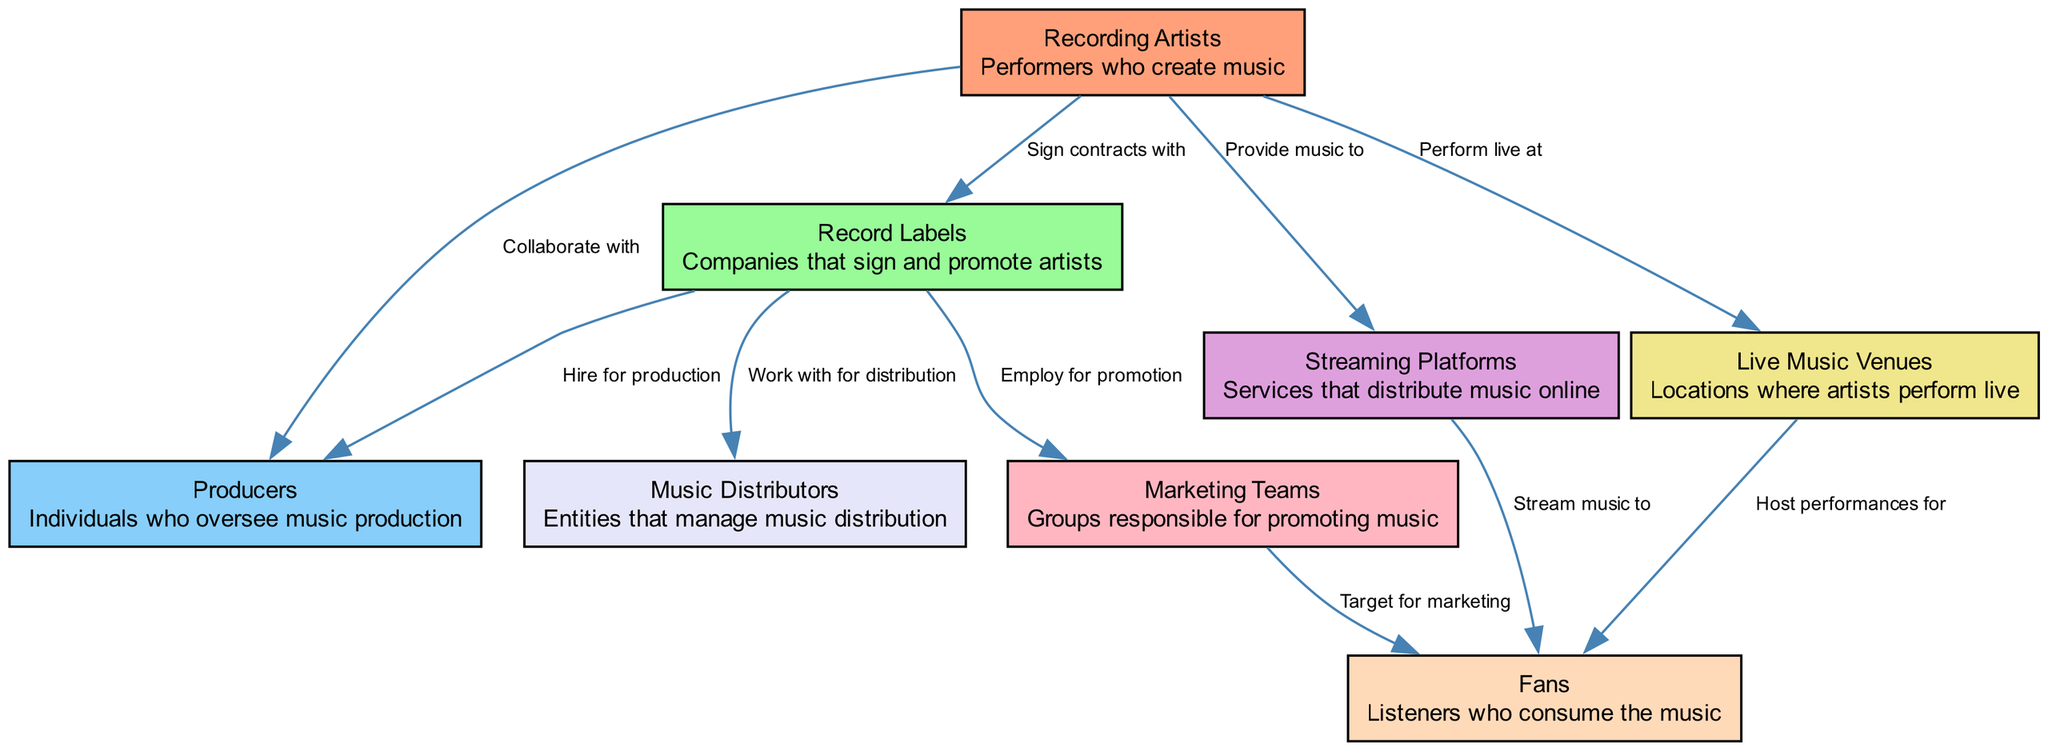What are the key players in the music industry shown in the diagram? The diagram lists eight key players: Recording Artists, Record Labels, Producers, Streaming Platforms, Live Music Venues, Music Distributors, Marketing Teams, and Fans.
Answer: Recording Artists, Record Labels, Producers, Streaming Platforms, Live Music Venues, Music Distributors, Marketing Teams, Fans Which node has a direct relationship with both Producers and Marketing Teams? The Record Labels node has edges leading to both Producers (hired for production) and Marketing Teams (employed for promotion), indicating its relationship with both.
Answer: Record Labels How many total nodes are represented in the diagram? Counting the nodes listed in the data, there are 8 unique key players represented in the diagram.
Answer: 8 What relationship does Live Music Venues have with Fans? The Live Music Venues node connects to the Fans node through the edge labeled "Host performances for", indicating that Live Music Venues directly engage with Fans.
Answer: Host performances for Which node provides music to Streaming Platforms? The Recording Artists node is responsible for providing music to the Streaming Platforms, as shown by the directed edge labeled "Provide music to."
Answer: Provide music to Which entity works with Record Labels for music distribution? Music Distributors are directly connected to Record Labels with the edge labeled "Work with for distribution," indicating their collaborative role in managing music distribution.
Answer: Work with for distribution What is the connection flow between Recording Artists and Fans? The flow starts with Recording Artists providing music to Streaming Platforms, which then stream music to Fans. Thus, the connection reflects how artistic output reaches the listener.
Answer: Provide music to, Stream music to Which node represents the performers that create music? The node labeled "Recording Artists" is specifically defined as performers who create music, serving a central role in the music industry ecosystem.
Answer: Recording Artists 